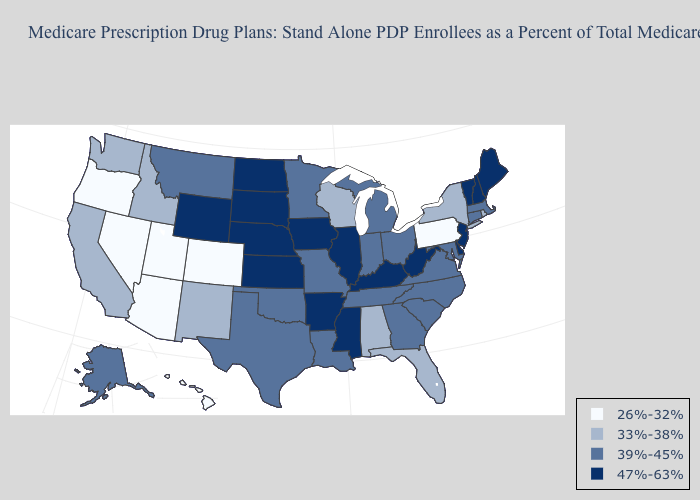Which states hav the highest value in the MidWest?
Write a very short answer. Iowa, Illinois, Kansas, North Dakota, Nebraska, South Dakota. Which states have the highest value in the USA?
Quick response, please. Arkansas, Delaware, Iowa, Illinois, Kansas, Kentucky, Maine, Mississippi, North Dakota, Nebraska, New Hampshire, New Jersey, South Dakota, Vermont, West Virginia, Wyoming. Name the states that have a value in the range 33%-38%?
Short answer required. Alabama, California, Florida, Idaho, New Mexico, New York, Rhode Island, Washington, Wisconsin. Name the states that have a value in the range 39%-45%?
Write a very short answer. Alaska, Connecticut, Georgia, Indiana, Louisiana, Massachusetts, Maryland, Michigan, Minnesota, Missouri, Montana, North Carolina, Ohio, Oklahoma, South Carolina, Tennessee, Texas, Virginia. Does Massachusetts have the highest value in the Northeast?
Be succinct. No. What is the value of Michigan?
Short answer required. 39%-45%. Name the states that have a value in the range 47%-63%?
Be succinct. Arkansas, Delaware, Iowa, Illinois, Kansas, Kentucky, Maine, Mississippi, North Dakota, Nebraska, New Hampshire, New Jersey, South Dakota, Vermont, West Virginia, Wyoming. What is the highest value in the MidWest ?
Be succinct. 47%-63%. Does the map have missing data?
Concise answer only. No. Does Pennsylvania have the lowest value in the Northeast?
Quick response, please. Yes. Which states have the lowest value in the USA?
Quick response, please. Arizona, Colorado, Hawaii, Nevada, Oregon, Pennsylvania, Utah. Does Arizona have the lowest value in the USA?
Keep it brief. Yes. Name the states that have a value in the range 47%-63%?
Write a very short answer. Arkansas, Delaware, Iowa, Illinois, Kansas, Kentucky, Maine, Mississippi, North Dakota, Nebraska, New Hampshire, New Jersey, South Dakota, Vermont, West Virginia, Wyoming. What is the value of Arkansas?
Concise answer only. 47%-63%. Name the states that have a value in the range 33%-38%?
Keep it brief. Alabama, California, Florida, Idaho, New Mexico, New York, Rhode Island, Washington, Wisconsin. 